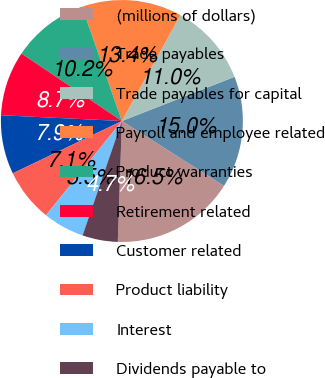Convert chart. <chart><loc_0><loc_0><loc_500><loc_500><pie_chart><fcel>(millions of dollars)<fcel>Trade payables<fcel>Trade payables for capital<fcel>Payroll and employee related<fcel>Product warranties<fcel>Retirement related<fcel>Customer related<fcel>Product liability<fcel>Interest<fcel>Dividends payable to<nl><fcel>16.53%<fcel>14.96%<fcel>11.02%<fcel>13.38%<fcel>10.24%<fcel>8.66%<fcel>7.88%<fcel>7.09%<fcel>5.52%<fcel>4.73%<nl></chart> 